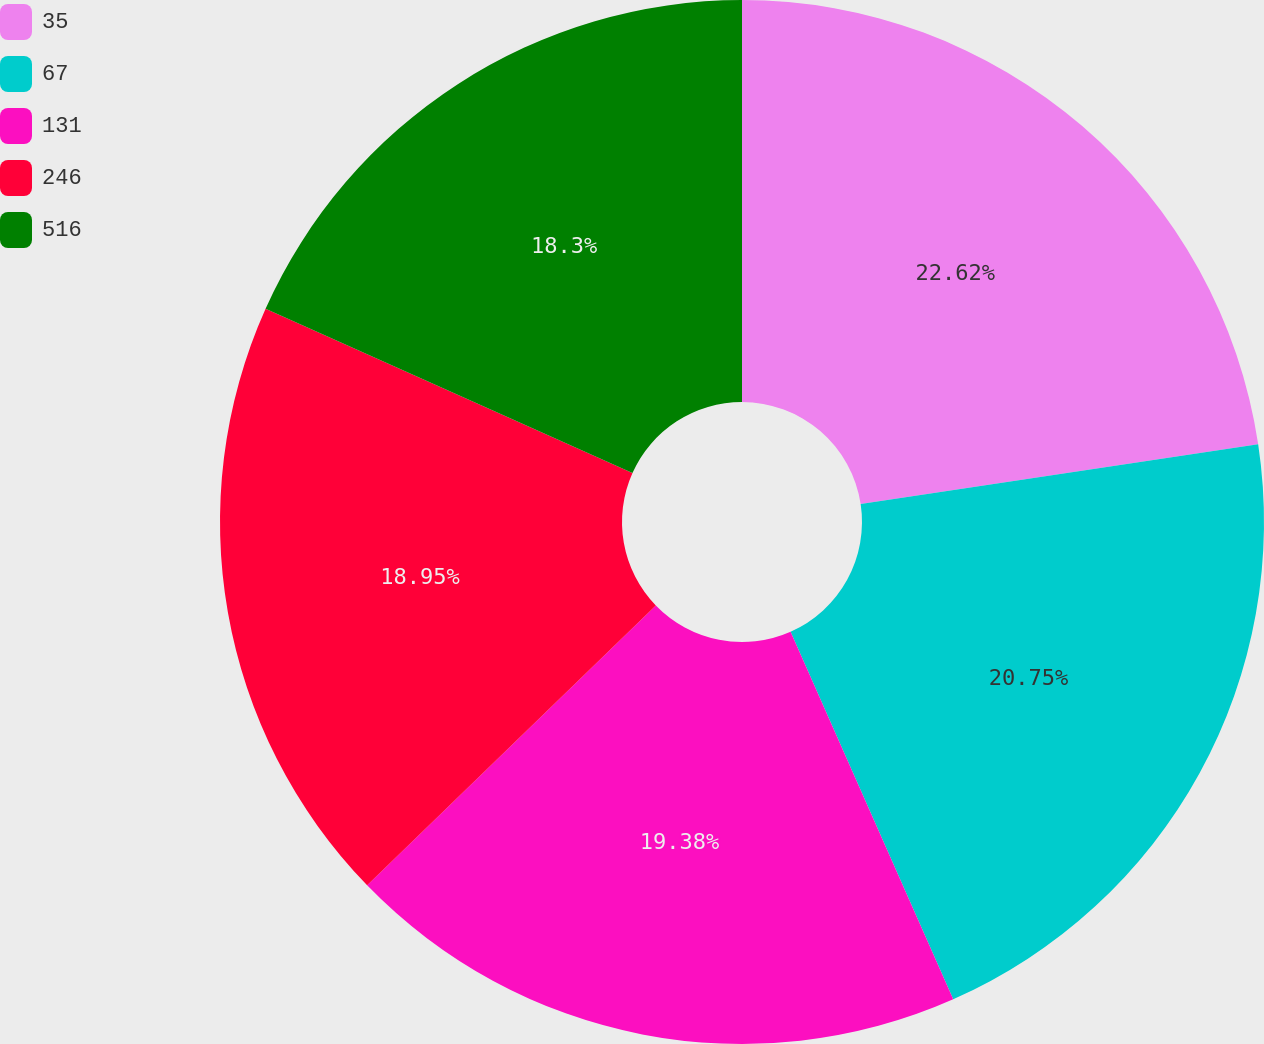Convert chart. <chart><loc_0><loc_0><loc_500><loc_500><pie_chart><fcel>35<fcel>67<fcel>131<fcel>246<fcel>516<nl><fcel>22.62%<fcel>20.75%<fcel>19.38%<fcel>18.95%<fcel>18.3%<nl></chart> 